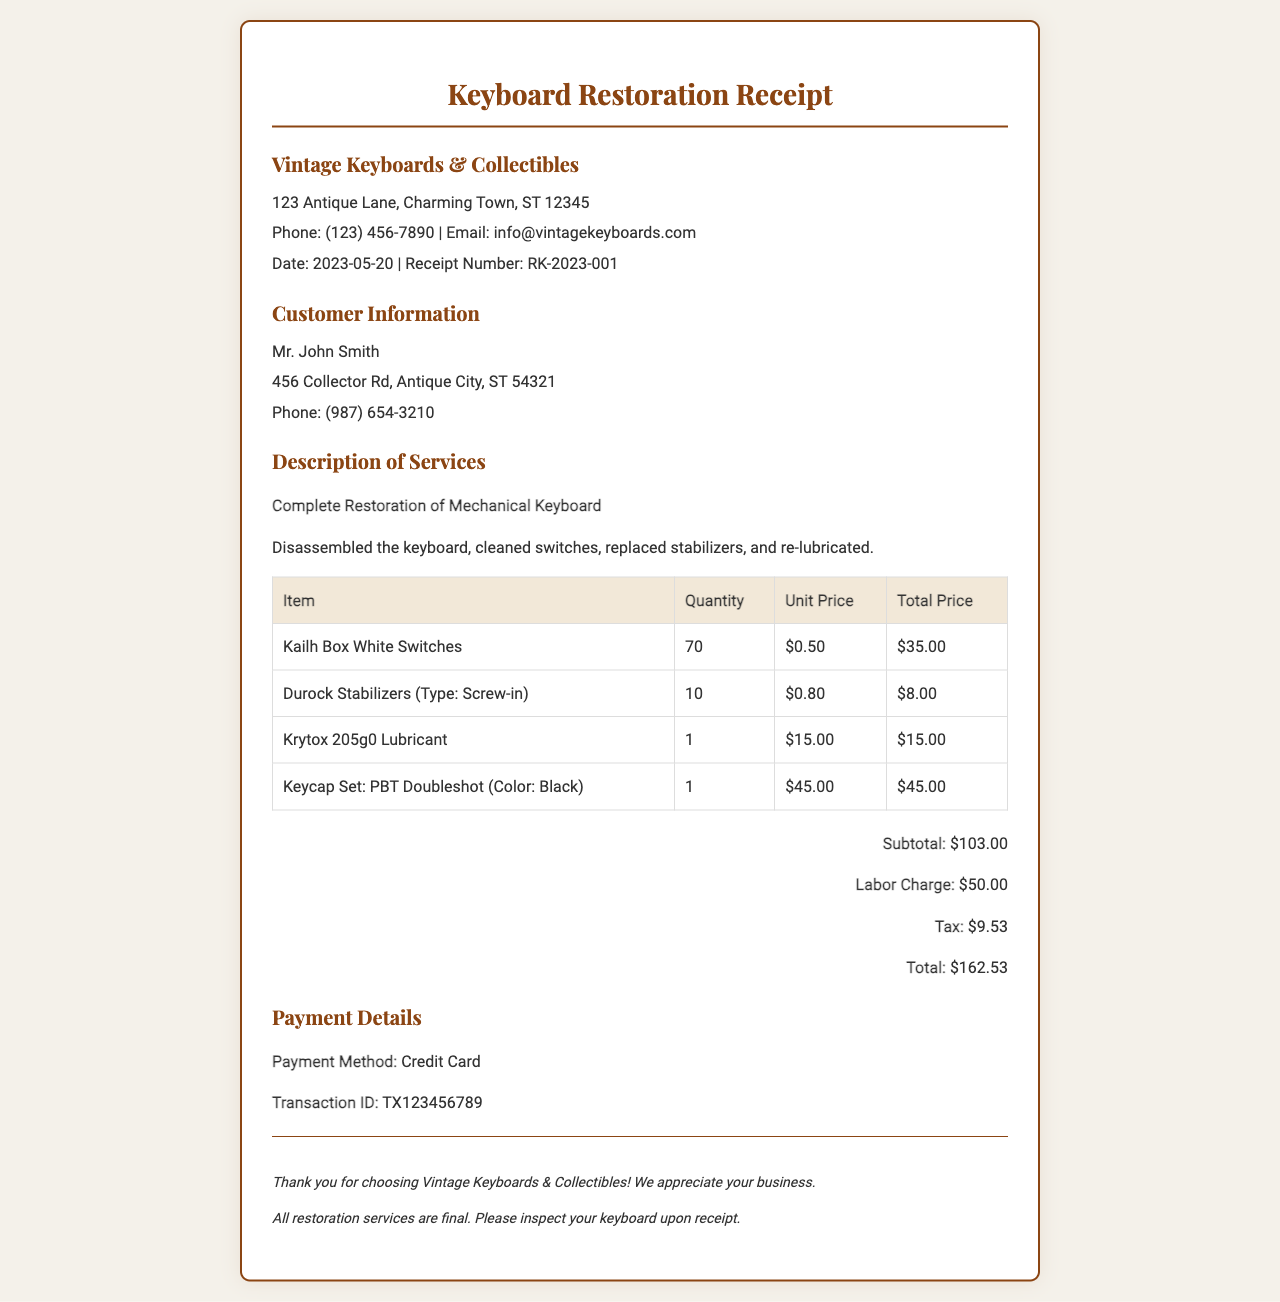What is the date of the receipt? The date of the receipt is explicitly stated in the document as the date when the service was completed.
Answer: 2023-05-20 Who is the customer? The customer's information is provided in the document, which includes their name and address.
Answer: Mr. John Smith What type of keyboard was restored? The document specifies the type of work done and the specific item being restored.
Answer: Mechanical Keyboard What is the labor charge? The labor charge is listed as a separate amount in the summary section of the receipt.
Answer: $50.00 How many Kailh Box White Switches were used? The quantity of Kailh Box White Switches is mentioned in the itemized breakdown of services and materials.
Answer: 70 What is the total amount charged? The total amount is calculated and presented clearly in the summary section of the document.
Answer: $162.53 What payment method was used? The payment method used for the transaction is explicitly mentioned in the payment details section.
Answer: Credit Card What is the receipt number? The receipt number is provided at the top of the document, which is unique to this transaction.
Answer: RK-2023-001 How much tax was included? The tax amount is detailed in the summary section as a distinct line item.
Answer: $9.53 